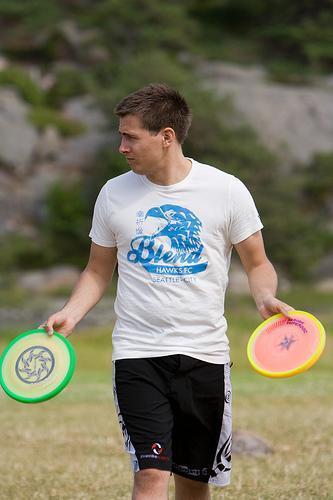How many people are in the picture?
Give a very brief answer. 1. How many frisbees are in the man's hands?
Give a very brief answer. 2. 